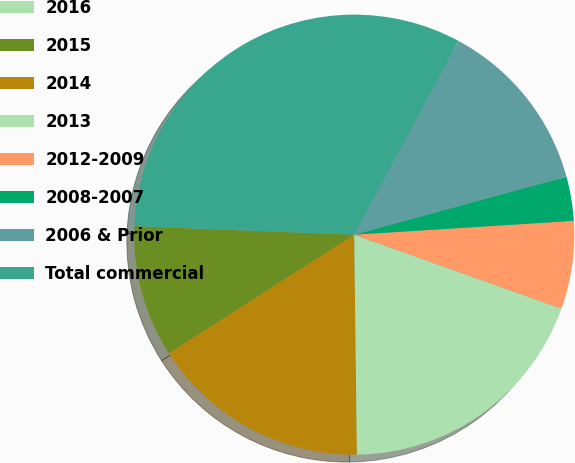<chart> <loc_0><loc_0><loc_500><loc_500><pie_chart><fcel>2016<fcel>2015<fcel>2014<fcel>2013<fcel>2012-2009<fcel>2008-2007<fcel>2006 & Prior<fcel>Total commercial<nl><fcel>0.01%<fcel>9.68%<fcel>16.13%<fcel>19.35%<fcel>6.46%<fcel>3.24%<fcel>12.9%<fcel>32.24%<nl></chart> 